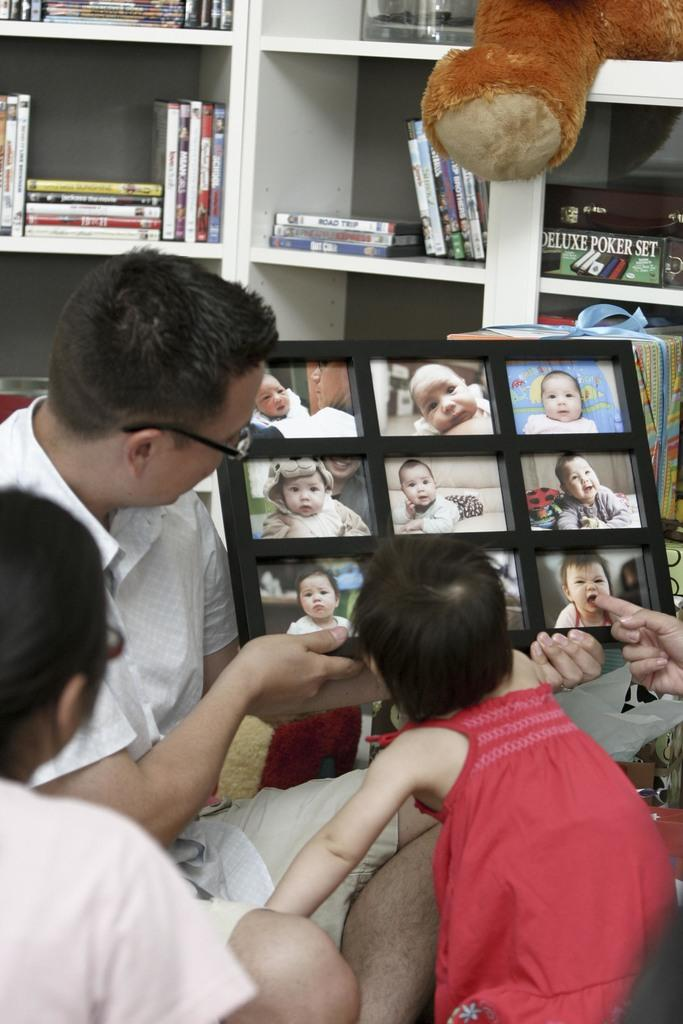What is the person in the image holding? The person is holding a photo frame in the image. How many children are present in the image? There are two children in the image. What can be seen in the background of the image? There is a bookshelf in the background of the image. What type of beast can be seen sitting on the throne in the image? There is no beast or throne present in the image; it features a person holding a photo frame and two children. What is the person using to rake the leaves in the image? There are no leaves or rake present in the image. 